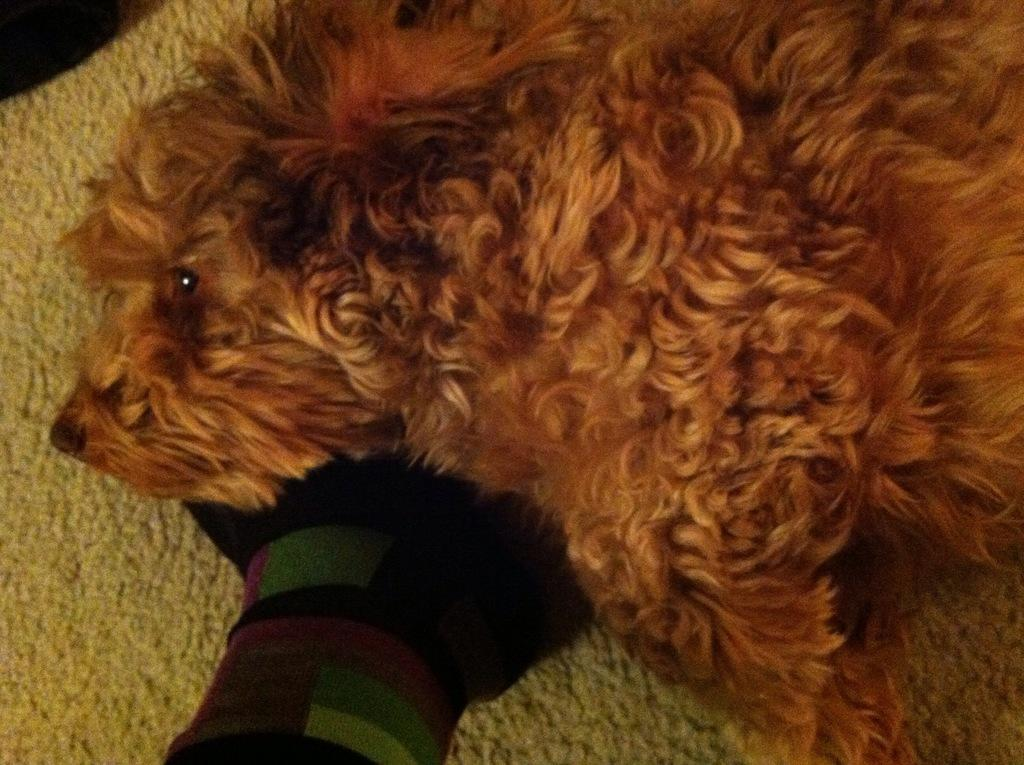What type of animal is present in the image? There is a dog in the image. What is located at the bottom of the image? There is a floor mat at the bottom of the image. How many apples are hanging from the dog's collar in the image? There are no apples present in the image, and the dog is not wearing a collar. Is there a veil covering the dog in the image? No, there is no veil present in the image, and the dog is not covered by any fabric. 